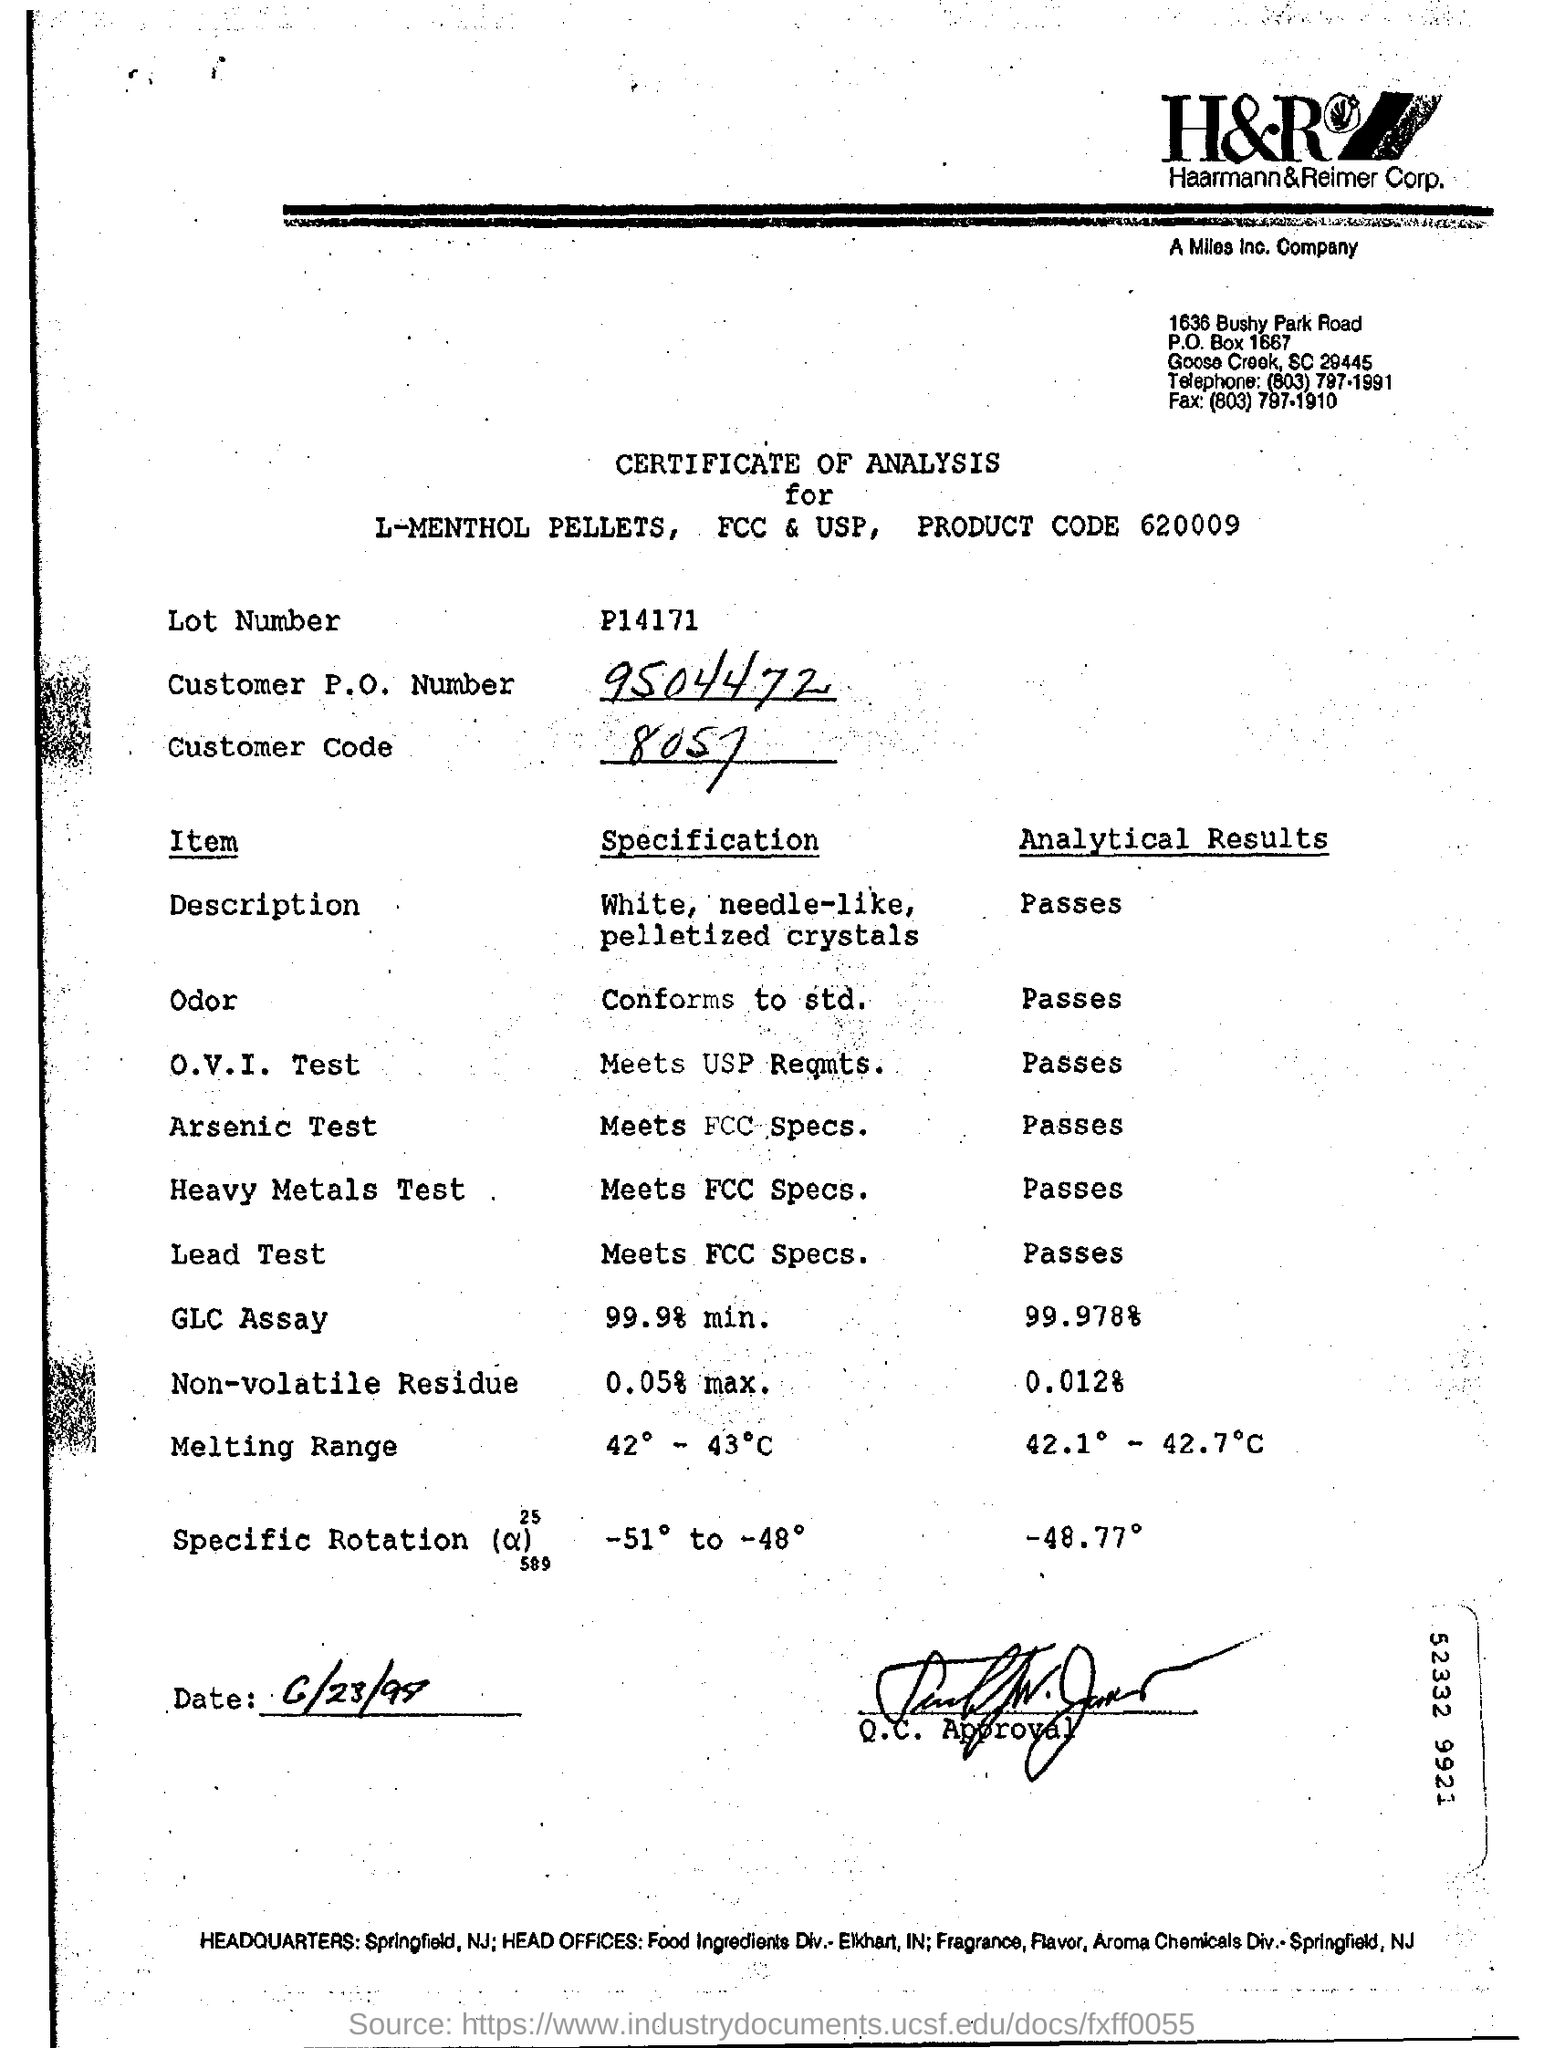Indicate a few pertinent items in this graphic. I want to find the customer code for 8057. Customer P.O. Number 9504472..." is a unique identifier assigned to a customer by a company for the purpose of tracking orders or transactions. 